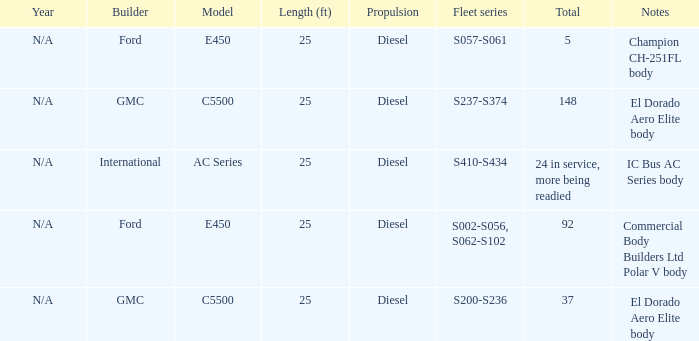Which builder has a fleet series of s057-s061? Ford. 